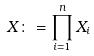Convert formula to latex. <formula><loc_0><loc_0><loc_500><loc_500>X \colon = \prod _ { i = 1 } ^ { n } X _ { i }</formula> 